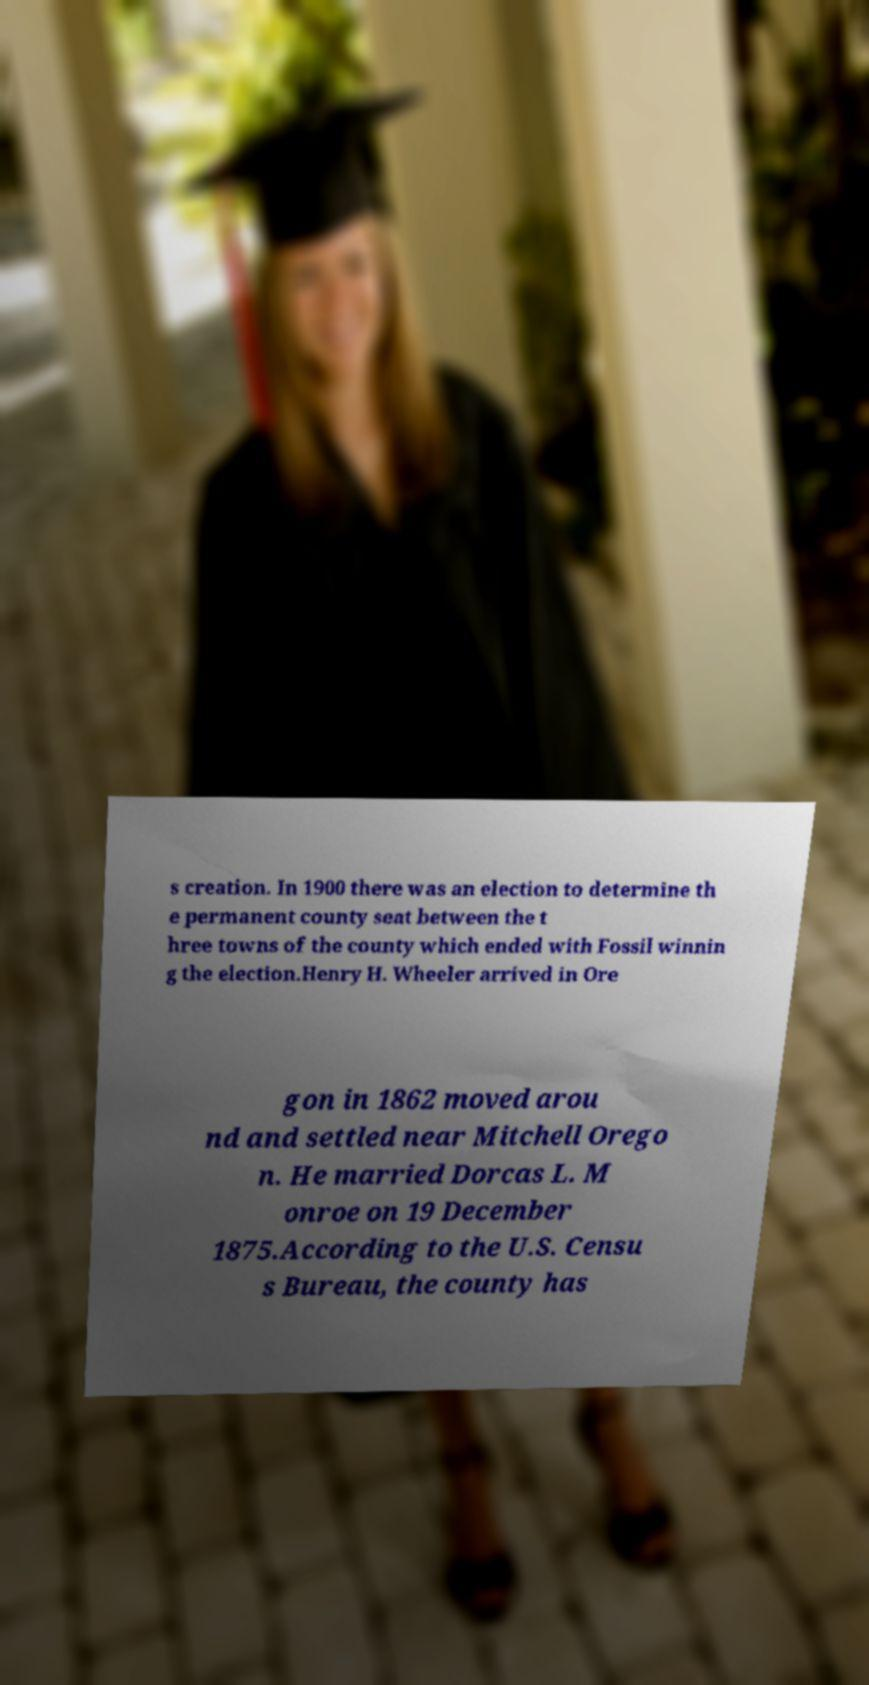I need the written content from this picture converted into text. Can you do that? s creation. In 1900 there was an election to determine th e permanent county seat between the t hree towns of the county which ended with Fossil winnin g the election.Henry H. Wheeler arrived in Ore gon in 1862 moved arou nd and settled near Mitchell Orego n. He married Dorcas L. M onroe on 19 December 1875.According to the U.S. Censu s Bureau, the county has 